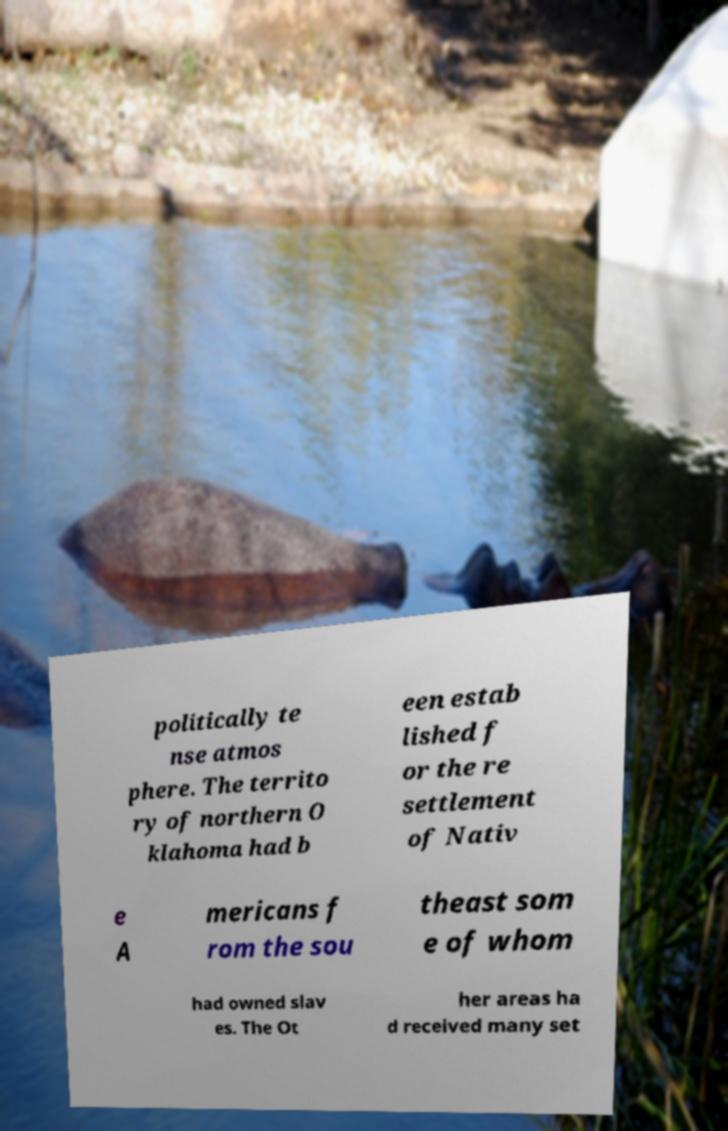Please identify and transcribe the text found in this image. politically te nse atmos phere. The territo ry of northern O klahoma had b een estab lished f or the re settlement of Nativ e A mericans f rom the sou theast som e of whom had owned slav es. The Ot her areas ha d received many set 